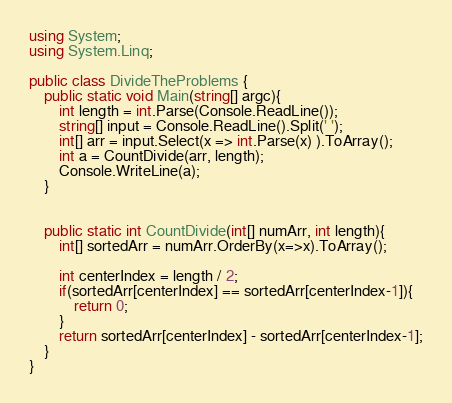<code> <loc_0><loc_0><loc_500><loc_500><_C#_>using System;
using System.Linq;

public class DivideTheProblems {
    public static void Main(string[] argc){
        int length = int.Parse(Console.ReadLine());
        string[] input = Console.ReadLine().Split(' ');
        int[] arr = input.Select(x => int.Parse(x) ).ToArray();
        int a = CountDivide(arr, length);
        Console.WriteLine(a);
    }


    public static int CountDivide(int[] numArr, int length){
        int[] sortedArr = numArr.OrderBy(x=>x).ToArray();

        int centerIndex = length / 2;
        if(sortedArr[centerIndex] == sortedArr[centerIndex-1]){
            return 0;
        }
        return sortedArr[centerIndex] - sortedArr[centerIndex-1];
    }
}</code> 